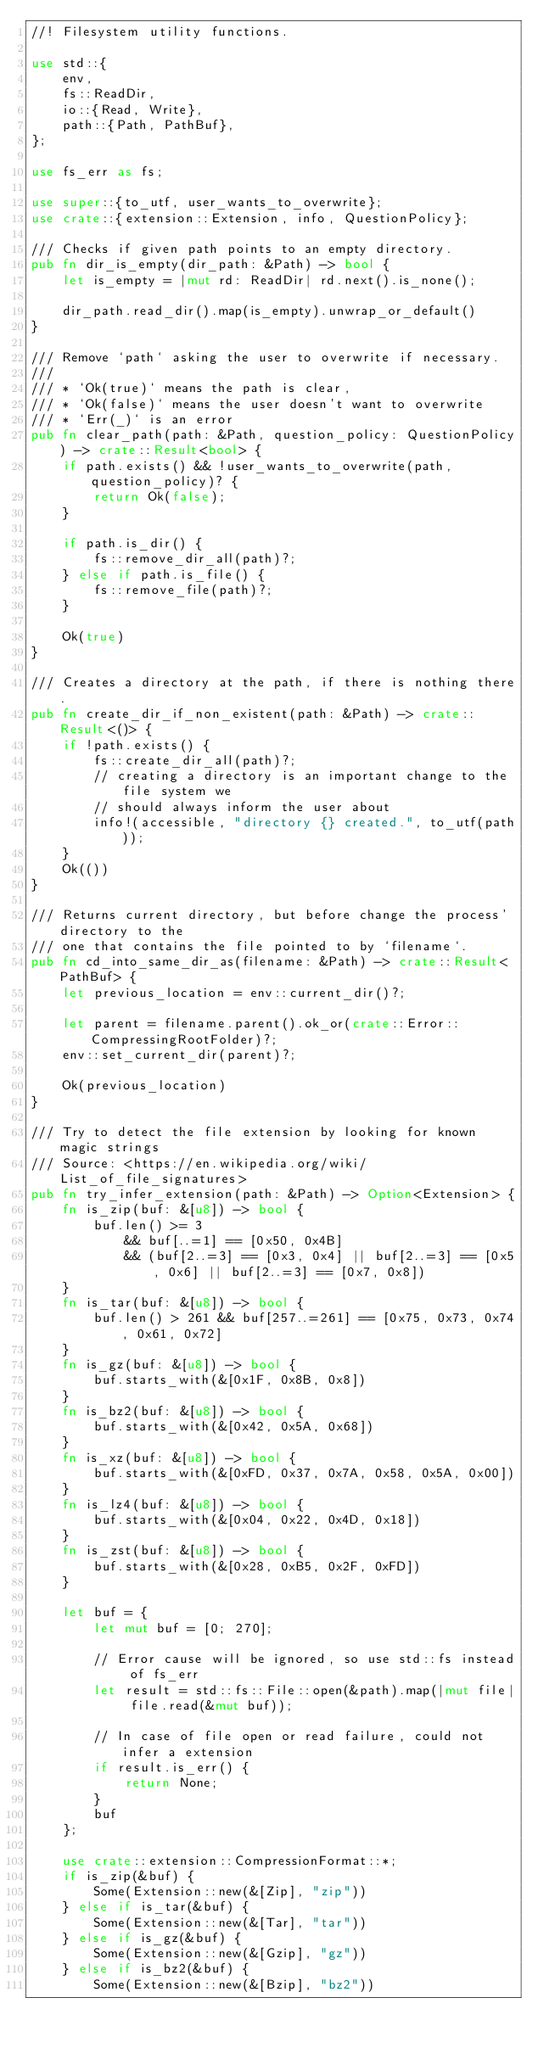<code> <loc_0><loc_0><loc_500><loc_500><_Rust_>//! Filesystem utility functions.

use std::{
    env,
    fs::ReadDir,
    io::{Read, Write},
    path::{Path, PathBuf},
};

use fs_err as fs;

use super::{to_utf, user_wants_to_overwrite};
use crate::{extension::Extension, info, QuestionPolicy};

/// Checks if given path points to an empty directory.
pub fn dir_is_empty(dir_path: &Path) -> bool {
    let is_empty = |mut rd: ReadDir| rd.next().is_none();

    dir_path.read_dir().map(is_empty).unwrap_or_default()
}

/// Remove `path` asking the user to overwrite if necessary.
///
/// * `Ok(true)` means the path is clear,
/// * `Ok(false)` means the user doesn't want to overwrite
/// * `Err(_)` is an error
pub fn clear_path(path: &Path, question_policy: QuestionPolicy) -> crate::Result<bool> {
    if path.exists() && !user_wants_to_overwrite(path, question_policy)? {
        return Ok(false);
    }

    if path.is_dir() {
        fs::remove_dir_all(path)?;
    } else if path.is_file() {
        fs::remove_file(path)?;
    }

    Ok(true)
}

/// Creates a directory at the path, if there is nothing there.
pub fn create_dir_if_non_existent(path: &Path) -> crate::Result<()> {
    if !path.exists() {
        fs::create_dir_all(path)?;
        // creating a directory is an important change to the file system we
        // should always inform the user about
        info!(accessible, "directory {} created.", to_utf(path));
    }
    Ok(())
}

/// Returns current directory, but before change the process' directory to the
/// one that contains the file pointed to by `filename`.
pub fn cd_into_same_dir_as(filename: &Path) -> crate::Result<PathBuf> {
    let previous_location = env::current_dir()?;

    let parent = filename.parent().ok_or(crate::Error::CompressingRootFolder)?;
    env::set_current_dir(parent)?;

    Ok(previous_location)
}

/// Try to detect the file extension by looking for known magic strings
/// Source: <https://en.wikipedia.org/wiki/List_of_file_signatures>
pub fn try_infer_extension(path: &Path) -> Option<Extension> {
    fn is_zip(buf: &[u8]) -> bool {
        buf.len() >= 3
            && buf[..=1] == [0x50, 0x4B]
            && (buf[2..=3] == [0x3, 0x4] || buf[2..=3] == [0x5, 0x6] || buf[2..=3] == [0x7, 0x8])
    }
    fn is_tar(buf: &[u8]) -> bool {
        buf.len() > 261 && buf[257..=261] == [0x75, 0x73, 0x74, 0x61, 0x72]
    }
    fn is_gz(buf: &[u8]) -> bool {
        buf.starts_with(&[0x1F, 0x8B, 0x8])
    }
    fn is_bz2(buf: &[u8]) -> bool {
        buf.starts_with(&[0x42, 0x5A, 0x68])
    }
    fn is_xz(buf: &[u8]) -> bool {
        buf.starts_with(&[0xFD, 0x37, 0x7A, 0x58, 0x5A, 0x00])
    }
    fn is_lz4(buf: &[u8]) -> bool {
        buf.starts_with(&[0x04, 0x22, 0x4D, 0x18])
    }
    fn is_zst(buf: &[u8]) -> bool {
        buf.starts_with(&[0x28, 0xB5, 0x2F, 0xFD])
    }

    let buf = {
        let mut buf = [0; 270];

        // Error cause will be ignored, so use std::fs instead of fs_err
        let result = std::fs::File::open(&path).map(|mut file| file.read(&mut buf));

        // In case of file open or read failure, could not infer a extension
        if result.is_err() {
            return None;
        }
        buf
    };

    use crate::extension::CompressionFormat::*;
    if is_zip(&buf) {
        Some(Extension::new(&[Zip], "zip"))
    } else if is_tar(&buf) {
        Some(Extension::new(&[Tar], "tar"))
    } else if is_gz(&buf) {
        Some(Extension::new(&[Gzip], "gz"))
    } else if is_bz2(&buf) {
        Some(Extension::new(&[Bzip], "bz2"))</code> 